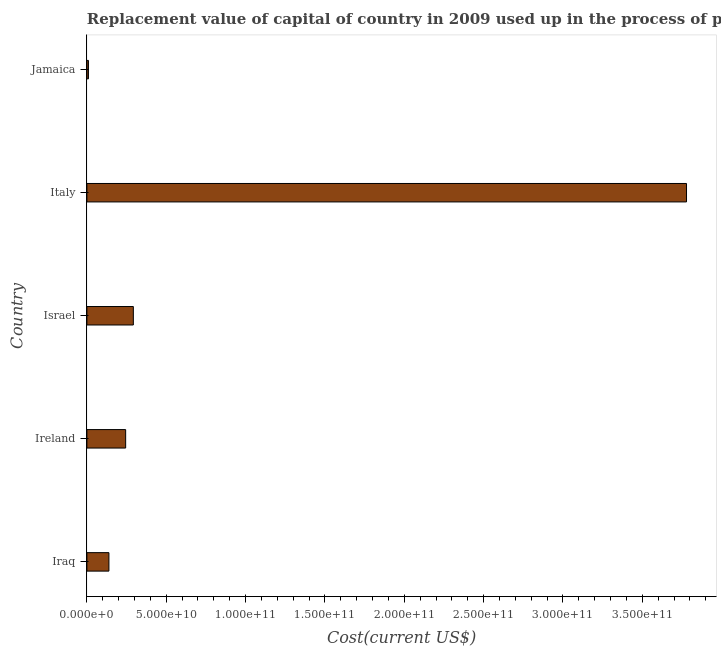What is the title of the graph?
Give a very brief answer. Replacement value of capital of country in 2009 used up in the process of production. What is the label or title of the X-axis?
Offer a very short reply. Cost(current US$). What is the label or title of the Y-axis?
Ensure brevity in your answer.  Country. What is the consumption of fixed capital in Italy?
Your answer should be compact. 3.78e+11. Across all countries, what is the maximum consumption of fixed capital?
Offer a very short reply. 3.78e+11. Across all countries, what is the minimum consumption of fixed capital?
Ensure brevity in your answer.  9.71e+08. In which country was the consumption of fixed capital minimum?
Keep it short and to the point. Jamaica. What is the sum of the consumption of fixed capital?
Your answer should be very brief. 4.46e+11. What is the difference between the consumption of fixed capital in Israel and Jamaica?
Your response must be concise. 2.83e+1. What is the average consumption of fixed capital per country?
Provide a short and direct response. 8.93e+1. What is the median consumption of fixed capital?
Keep it short and to the point. 2.44e+1. What is the ratio of the consumption of fixed capital in Ireland to that in Italy?
Provide a succinct answer. 0.07. Is the difference between the consumption of fixed capital in Italy and Jamaica greater than the difference between any two countries?
Make the answer very short. Yes. What is the difference between the highest and the second highest consumption of fixed capital?
Offer a terse response. 3.49e+11. What is the difference between the highest and the lowest consumption of fixed capital?
Provide a short and direct response. 3.77e+11. In how many countries, is the consumption of fixed capital greater than the average consumption of fixed capital taken over all countries?
Give a very brief answer. 1. What is the difference between two consecutive major ticks on the X-axis?
Your answer should be compact. 5.00e+1. Are the values on the major ticks of X-axis written in scientific E-notation?
Your answer should be very brief. Yes. What is the Cost(current US$) in Iraq?
Your answer should be compact. 1.39e+1. What is the Cost(current US$) in Ireland?
Your answer should be very brief. 2.44e+1. What is the Cost(current US$) in Israel?
Provide a succinct answer. 2.93e+1. What is the Cost(current US$) in Italy?
Your answer should be compact. 3.78e+11. What is the Cost(current US$) of Jamaica?
Ensure brevity in your answer.  9.71e+08. What is the difference between the Cost(current US$) in Iraq and Ireland?
Offer a terse response. -1.05e+1. What is the difference between the Cost(current US$) in Iraq and Israel?
Your answer should be compact. -1.54e+1. What is the difference between the Cost(current US$) in Iraq and Italy?
Ensure brevity in your answer.  -3.64e+11. What is the difference between the Cost(current US$) in Iraq and Jamaica?
Your answer should be compact. 1.29e+1. What is the difference between the Cost(current US$) in Ireland and Israel?
Your response must be concise. -4.84e+09. What is the difference between the Cost(current US$) in Ireland and Italy?
Offer a very short reply. -3.53e+11. What is the difference between the Cost(current US$) in Ireland and Jamaica?
Offer a terse response. 2.35e+1. What is the difference between the Cost(current US$) in Israel and Italy?
Offer a terse response. -3.49e+11. What is the difference between the Cost(current US$) in Israel and Jamaica?
Your answer should be compact. 2.83e+1. What is the difference between the Cost(current US$) in Italy and Jamaica?
Keep it short and to the point. 3.77e+11. What is the ratio of the Cost(current US$) in Iraq to that in Ireland?
Provide a succinct answer. 0.57. What is the ratio of the Cost(current US$) in Iraq to that in Israel?
Your response must be concise. 0.47. What is the ratio of the Cost(current US$) in Iraq to that in Italy?
Ensure brevity in your answer.  0.04. What is the ratio of the Cost(current US$) in Iraq to that in Jamaica?
Offer a terse response. 14.3. What is the ratio of the Cost(current US$) in Ireland to that in Israel?
Keep it short and to the point. 0.83. What is the ratio of the Cost(current US$) in Ireland to that in Italy?
Give a very brief answer. 0.07. What is the ratio of the Cost(current US$) in Ireland to that in Jamaica?
Offer a very short reply. 25.16. What is the ratio of the Cost(current US$) in Israel to that in Italy?
Your answer should be compact. 0.08. What is the ratio of the Cost(current US$) in Israel to that in Jamaica?
Make the answer very short. 30.16. What is the ratio of the Cost(current US$) in Italy to that in Jamaica?
Provide a succinct answer. 389.24. 